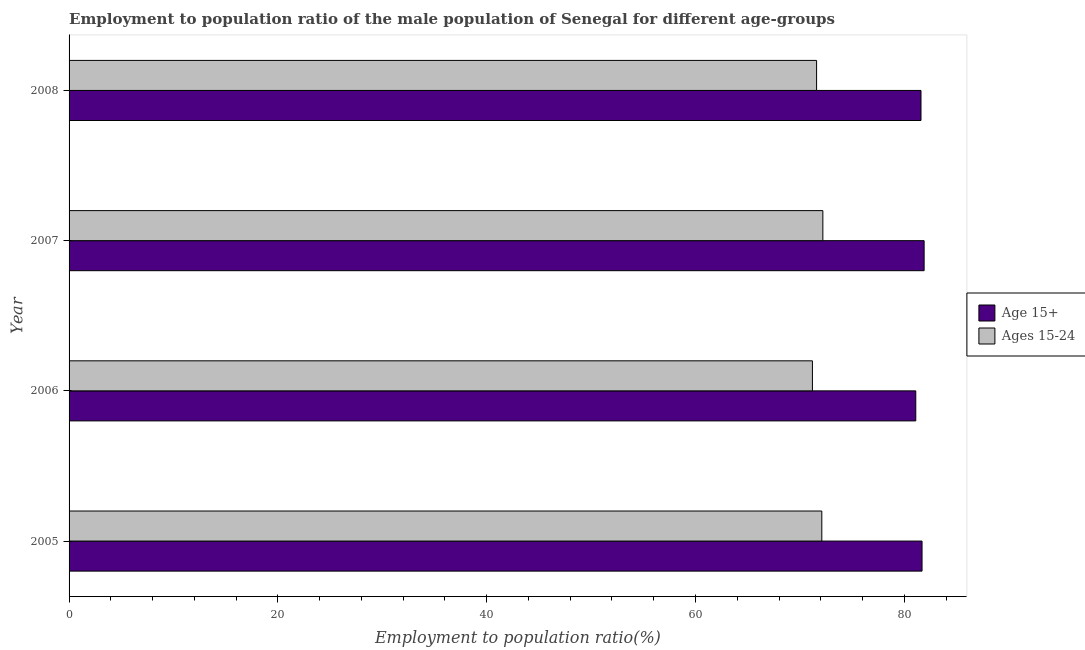How many groups of bars are there?
Your answer should be compact. 4. Are the number of bars on each tick of the Y-axis equal?
Provide a succinct answer. Yes. How many bars are there on the 3rd tick from the top?
Your answer should be very brief. 2. How many bars are there on the 4th tick from the bottom?
Your response must be concise. 2. What is the label of the 2nd group of bars from the top?
Ensure brevity in your answer.  2007. In how many cases, is the number of bars for a given year not equal to the number of legend labels?
Offer a terse response. 0. What is the employment to population ratio(age 15+) in 2007?
Your response must be concise. 81.9. Across all years, what is the maximum employment to population ratio(age 15+)?
Your response must be concise. 81.9. Across all years, what is the minimum employment to population ratio(age 15+)?
Your response must be concise. 81.1. In which year was the employment to population ratio(age 15-24) minimum?
Give a very brief answer. 2006. What is the total employment to population ratio(age 15+) in the graph?
Keep it short and to the point. 326.3. What is the difference between the employment to population ratio(age 15+) in 2006 and that in 2008?
Give a very brief answer. -0.5. What is the difference between the employment to population ratio(age 15-24) in 2008 and the employment to population ratio(age 15+) in 2007?
Your answer should be compact. -10.3. What is the average employment to population ratio(age 15+) per year?
Your answer should be compact. 81.58. What is the difference between the highest and the lowest employment to population ratio(age 15+)?
Provide a short and direct response. 0.8. In how many years, is the employment to population ratio(age 15-24) greater than the average employment to population ratio(age 15-24) taken over all years?
Make the answer very short. 2. What does the 2nd bar from the top in 2006 represents?
Your answer should be compact. Age 15+. What does the 2nd bar from the bottom in 2008 represents?
Provide a short and direct response. Ages 15-24. Are the values on the major ticks of X-axis written in scientific E-notation?
Your answer should be compact. No. Does the graph contain any zero values?
Give a very brief answer. No. Does the graph contain grids?
Ensure brevity in your answer.  No. How many legend labels are there?
Offer a terse response. 2. What is the title of the graph?
Make the answer very short. Employment to population ratio of the male population of Senegal for different age-groups. Does "Diesel" appear as one of the legend labels in the graph?
Provide a succinct answer. No. What is the label or title of the X-axis?
Offer a very short reply. Employment to population ratio(%). What is the Employment to population ratio(%) of Age 15+ in 2005?
Offer a very short reply. 81.7. What is the Employment to population ratio(%) of Ages 15-24 in 2005?
Give a very brief answer. 72.1. What is the Employment to population ratio(%) in Age 15+ in 2006?
Ensure brevity in your answer.  81.1. What is the Employment to population ratio(%) of Ages 15-24 in 2006?
Give a very brief answer. 71.2. What is the Employment to population ratio(%) in Age 15+ in 2007?
Your answer should be compact. 81.9. What is the Employment to population ratio(%) in Ages 15-24 in 2007?
Your response must be concise. 72.2. What is the Employment to population ratio(%) of Age 15+ in 2008?
Give a very brief answer. 81.6. What is the Employment to population ratio(%) of Ages 15-24 in 2008?
Make the answer very short. 71.6. Across all years, what is the maximum Employment to population ratio(%) of Age 15+?
Your answer should be very brief. 81.9. Across all years, what is the maximum Employment to population ratio(%) of Ages 15-24?
Provide a succinct answer. 72.2. Across all years, what is the minimum Employment to population ratio(%) of Age 15+?
Your answer should be compact. 81.1. Across all years, what is the minimum Employment to population ratio(%) in Ages 15-24?
Your answer should be compact. 71.2. What is the total Employment to population ratio(%) of Age 15+ in the graph?
Provide a short and direct response. 326.3. What is the total Employment to population ratio(%) of Ages 15-24 in the graph?
Offer a terse response. 287.1. What is the difference between the Employment to population ratio(%) in Ages 15-24 in 2005 and that in 2006?
Keep it short and to the point. 0.9. What is the difference between the Employment to population ratio(%) in Ages 15-24 in 2005 and that in 2008?
Make the answer very short. 0.5. What is the difference between the Employment to population ratio(%) in Ages 15-24 in 2006 and that in 2007?
Your response must be concise. -1. What is the difference between the Employment to population ratio(%) of Ages 15-24 in 2007 and that in 2008?
Ensure brevity in your answer.  0.6. What is the difference between the Employment to population ratio(%) in Age 15+ in 2005 and the Employment to population ratio(%) in Ages 15-24 in 2006?
Your answer should be compact. 10.5. What is the difference between the Employment to population ratio(%) in Age 15+ in 2005 and the Employment to population ratio(%) in Ages 15-24 in 2007?
Make the answer very short. 9.5. What is the difference between the Employment to population ratio(%) of Age 15+ in 2005 and the Employment to population ratio(%) of Ages 15-24 in 2008?
Provide a succinct answer. 10.1. What is the difference between the Employment to population ratio(%) in Age 15+ in 2006 and the Employment to population ratio(%) in Ages 15-24 in 2007?
Offer a very short reply. 8.9. What is the difference between the Employment to population ratio(%) in Age 15+ in 2006 and the Employment to population ratio(%) in Ages 15-24 in 2008?
Give a very brief answer. 9.5. What is the difference between the Employment to population ratio(%) in Age 15+ in 2007 and the Employment to population ratio(%) in Ages 15-24 in 2008?
Keep it short and to the point. 10.3. What is the average Employment to population ratio(%) in Age 15+ per year?
Provide a succinct answer. 81.58. What is the average Employment to population ratio(%) of Ages 15-24 per year?
Keep it short and to the point. 71.78. In the year 2005, what is the difference between the Employment to population ratio(%) in Age 15+ and Employment to population ratio(%) in Ages 15-24?
Offer a terse response. 9.6. In the year 2006, what is the difference between the Employment to population ratio(%) in Age 15+ and Employment to population ratio(%) in Ages 15-24?
Provide a succinct answer. 9.9. What is the ratio of the Employment to population ratio(%) of Age 15+ in 2005 to that in 2006?
Offer a very short reply. 1.01. What is the ratio of the Employment to population ratio(%) of Ages 15-24 in 2005 to that in 2006?
Keep it short and to the point. 1.01. What is the ratio of the Employment to population ratio(%) in Ages 15-24 in 2005 to that in 2007?
Make the answer very short. 1. What is the ratio of the Employment to population ratio(%) of Ages 15-24 in 2005 to that in 2008?
Keep it short and to the point. 1.01. What is the ratio of the Employment to population ratio(%) of Age 15+ in 2006 to that in 2007?
Your response must be concise. 0.99. What is the ratio of the Employment to population ratio(%) of Ages 15-24 in 2006 to that in 2007?
Your answer should be very brief. 0.99. What is the ratio of the Employment to population ratio(%) in Ages 15-24 in 2007 to that in 2008?
Your response must be concise. 1.01. What is the difference between the highest and the second highest Employment to population ratio(%) of Age 15+?
Keep it short and to the point. 0.2. What is the difference between the highest and the lowest Employment to population ratio(%) in Ages 15-24?
Your answer should be very brief. 1. 